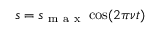Convert formula to latex. <formula><loc_0><loc_0><loc_500><loc_500>s = s _ { m a x } \cos ( 2 \pi \nu t )</formula> 